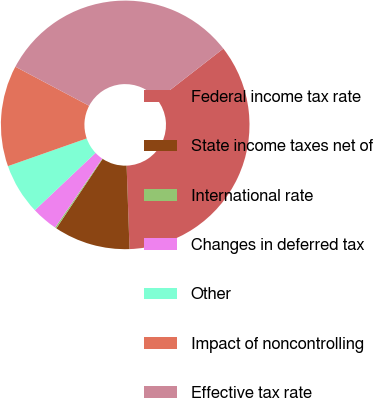Convert chart to OTSL. <chart><loc_0><loc_0><loc_500><loc_500><pie_chart><fcel>Federal income tax rate<fcel>State income taxes net of<fcel>International rate<fcel>Changes in deferred tax<fcel>Other<fcel>Impact of noncontrolling<fcel>Effective tax rate<nl><fcel>34.96%<fcel>9.9%<fcel>0.19%<fcel>3.42%<fcel>6.66%<fcel>13.14%<fcel>31.73%<nl></chart> 